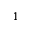<formula> <loc_0><loc_0><loc_500><loc_500>^ { 1 }</formula> 